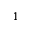<formula> <loc_0><loc_0><loc_500><loc_500>^ { 1 }</formula> 